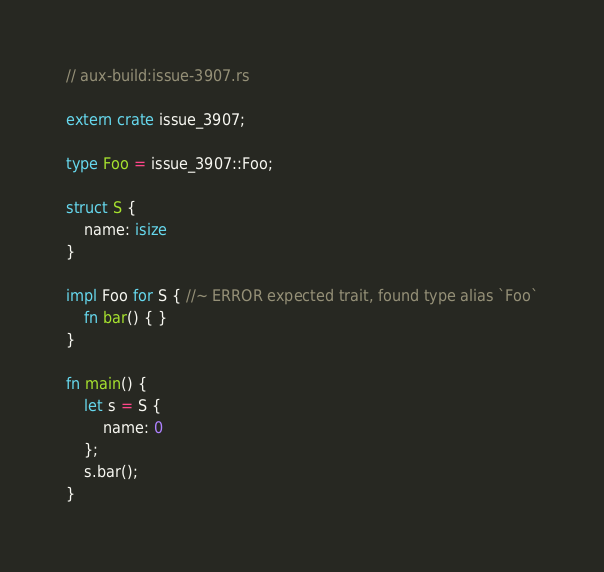<code> <loc_0><loc_0><loc_500><loc_500><_Rust_>// aux-build:issue-3907.rs

extern crate issue_3907;

type Foo = issue_3907::Foo;

struct S {
    name: isize
}

impl Foo for S { //~ ERROR expected trait, found type alias `Foo`
    fn bar() { }
}

fn main() {
    let s = S {
        name: 0
    };
    s.bar();
}
</code> 